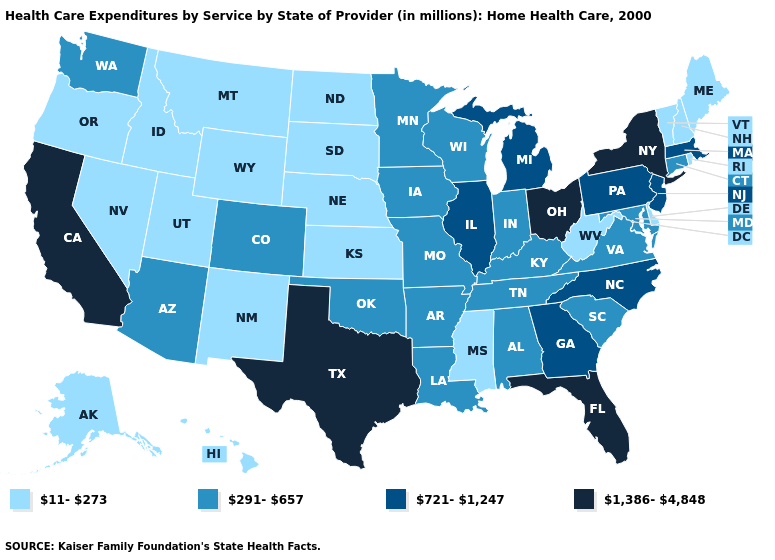What is the value of South Carolina?
Be succinct. 291-657. Name the states that have a value in the range 721-1,247?
Quick response, please. Georgia, Illinois, Massachusetts, Michigan, New Jersey, North Carolina, Pennsylvania. What is the value of California?
Be succinct. 1,386-4,848. What is the value of Ohio?
Quick response, please. 1,386-4,848. Does Florida have the highest value in the South?
Be succinct. Yes. What is the value of New Jersey?
Give a very brief answer. 721-1,247. What is the value of North Dakota?
Be succinct. 11-273. Does California have the highest value in the West?
Keep it brief. Yes. Does New York have the highest value in the Northeast?
Concise answer only. Yes. What is the value of Rhode Island?
Give a very brief answer. 11-273. Among the states that border Nevada , which have the highest value?
Write a very short answer. California. Which states have the lowest value in the West?
Concise answer only. Alaska, Hawaii, Idaho, Montana, Nevada, New Mexico, Oregon, Utah, Wyoming. What is the highest value in states that border Washington?
Write a very short answer. 11-273. What is the highest value in states that border South Carolina?
Answer briefly. 721-1,247. What is the highest value in the USA?
Give a very brief answer. 1,386-4,848. 